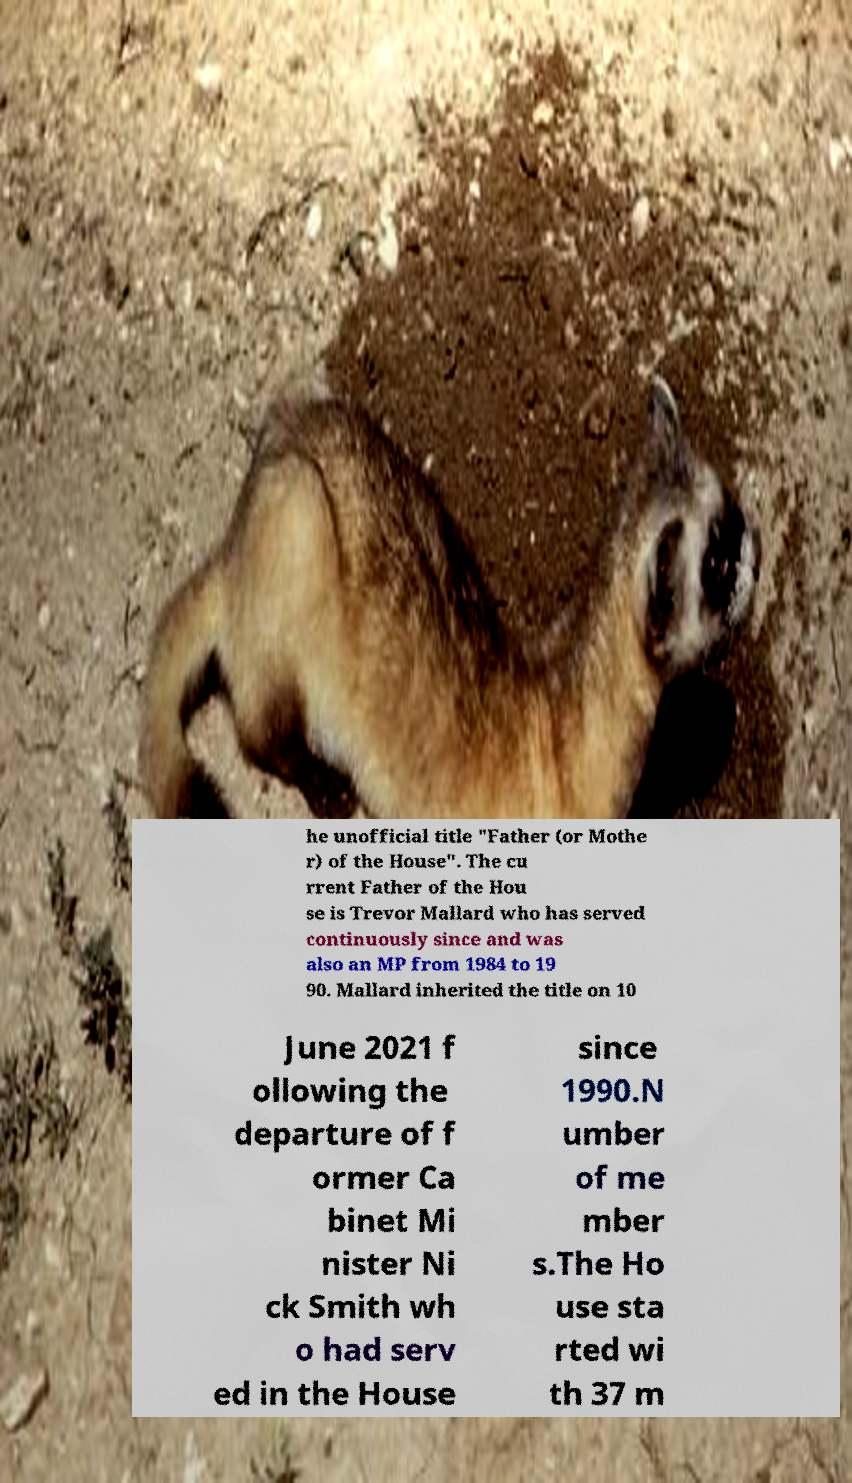What messages or text are displayed in this image? I need them in a readable, typed format. he unofficial title "Father (or Mothe r) of the House". The cu rrent Father of the Hou se is Trevor Mallard who has served continuously since and was also an MP from 1984 to 19 90. Mallard inherited the title on 10 June 2021 f ollowing the departure of f ormer Ca binet Mi nister Ni ck Smith wh o had serv ed in the House since 1990.N umber of me mber s.The Ho use sta rted wi th 37 m 